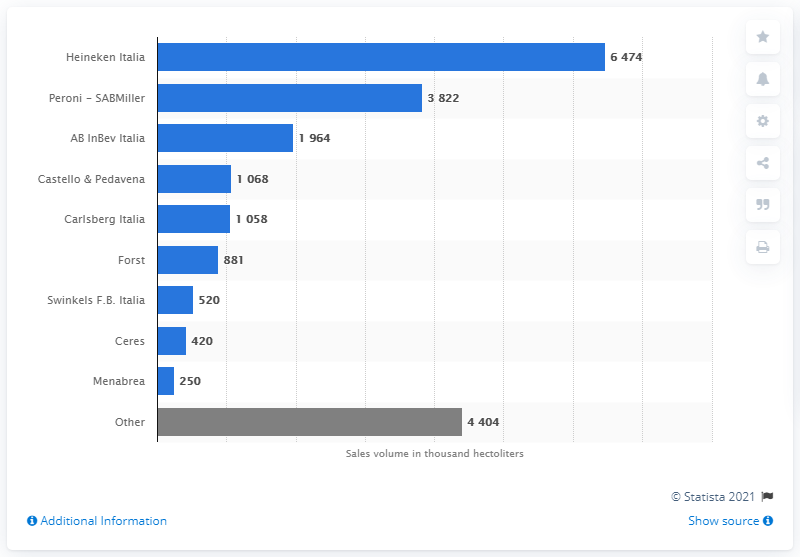List a handful of essential elements in this visual. Peroni, a beer brand produced by SABMiller, had the highest sales volume in Italy in 2019. 